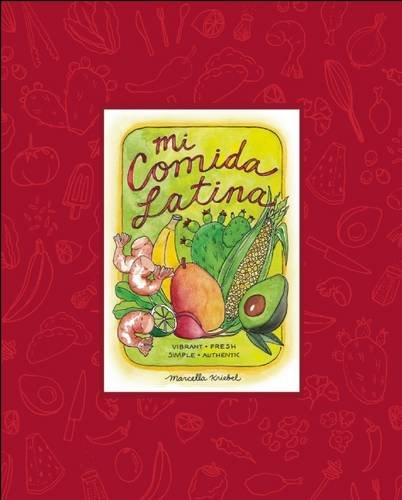What is the title of this book? The title of this colorful and inviting book is 'Mi Comida Latina: Vibrant, Fresh, Simple, Authentic', which suggests a celebration of Latin American cooking styles and ingredients. 